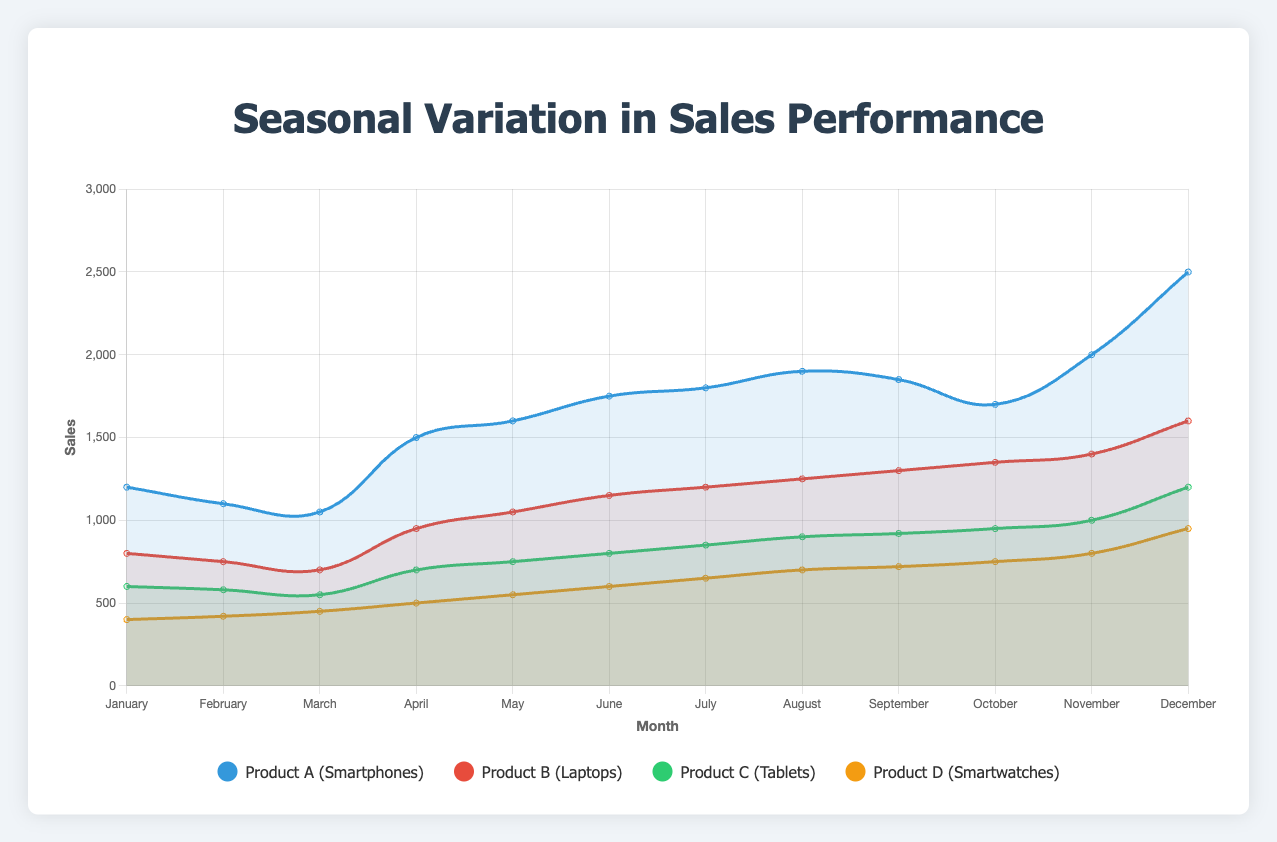Which product has the highest sales in December? By looking at the December data for all products: Product A (2500), Product B (1600), Product C (1200), and Product D (950), we see that Product A has the highest sales.
Answer: Product A What is the overall trend in sales for Product B throughout the year? By observing the curve for Product B, the sales start at 800 in January and gradually increase, peaking at 1600 in December, indicating a general upward trend.
Answer: Upward trend Which month has the lowest sales for Product C? By checking the sales data for Product C across all months, February has the lowest sales at 580.
Answer: February How do the sales of Product D in July compare to those in November? In July, the sales for Product D are 650, while in November, they are 800. This indicates that November sales are higher than July.
Answer: November is higher What is the average sale for Product A over the year? The total sales for Product A can be calculated by summing all the monthly sales: 1200 + 1100 + 1050 + 1500 + 1600 + 1750 + 1800 + 1900 + 1850 + 1700 + 2000 + 2500 = 20050. Dividing this by 12 (months) gives an average sales of 1670.83.
Answer: 1670.83 Which product shows the most stable sales pattern over the year? By visually comparing the fluctuation in the curves of all products, Product B shows the most stable sales pattern with gradual increases each month, without any sharp peaks or drops.
Answer: Product B During which month do we observe the highest combined sales for all products? Sum the sales for each product for every month: December (2500 + 1600 + 1200 + 950) has the highest total: 6250.
Answer: December What is the percentage increase in sales from January to December for Product C? The sales for Product C are 600 in January and 1200 in December. The increase is 1200 - 600 = 600. The percentage increase is (600/600) * 100 = 100%.
Answer: 100% Which product had the highest growth in sales from April to May? By calculating the difference in sales from April to May for each product: Product A (1600-1500=100), Product B (1050-950=100), Product C (750-700=50), and Product D (550-500=50). Product A and Product B both show the highest growth of 100 units.
Answer: Product A and Product B 